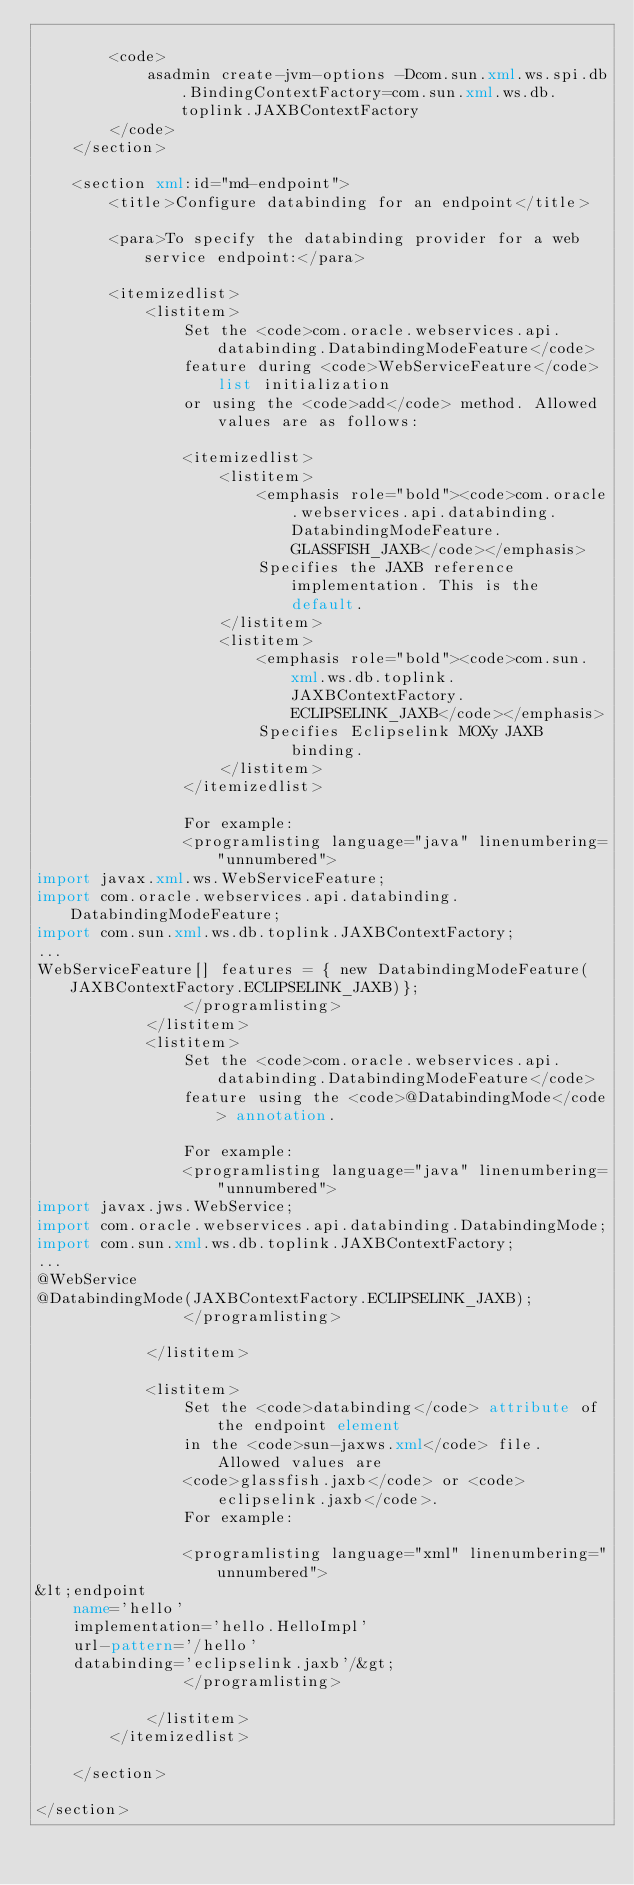<code> <loc_0><loc_0><loc_500><loc_500><_XML_>
        <code>
            asadmin create-jvm-options -Dcom.sun.xml.ws.spi.db.BindingContextFactory=com.sun.xml.ws.db.toplink.JAXBContextFactory
        </code>
    </section>

    <section xml:id="md-endpoint">
        <title>Configure databinding for an endpoint</title>

        <para>To specify the databinding provider for a web service endpoint:</para>

        <itemizedlist>
            <listitem>
                Set the <code>com.oracle.webservices.api.databinding.DatabindingModeFeature</code> 
                feature during <code>WebServiceFeature</code> list initialization
                or using the <code>add</code> method. Allowed values are as follows:

                <itemizedlist>
                    <listitem>
                        <emphasis role="bold"><code>com.oracle.webservices.api.databinding.DatabindingModeFeature.GLASSFISH_JAXB</code></emphasis>
                        Specifies the JAXB reference implementation. This is the default.
                    </listitem>
                    <listitem>
                        <emphasis role="bold"><code>com.sun.xml.ws.db.toplink.JAXBContextFactory.ECLIPSELINK_JAXB</code></emphasis>
                        Specifies Eclipselink MOXy JAXB binding.
                    </listitem>
                </itemizedlist>

                For example:
                <programlisting language="java" linenumbering="unnumbered">
import javax.xml.ws.WebServiceFeature;
import com.oracle.webservices.api.databinding.DatabindingModeFeature;
import com.sun.xml.ws.db.toplink.JAXBContextFactory;
...
WebServiceFeature[] features = { new DatabindingModeFeature(JAXBContextFactory.ECLIPSELINK_JAXB)};
                </programlisting>                    
            </listitem>
            <listitem>
                Set the <code>com.oracle.webservices.api.databinding.DatabindingModeFeature</code> 
                feature using the <code>@DatabindingMode</code> annotation.

                For example:
                <programlisting language="java" linenumbering="unnumbered">
import javax.jws.WebService;
import com.oracle.webservices.api.databinding.DatabindingMode;
import com.sun.xml.ws.db.toplink.JAXBContextFactory;
...
@WebService
@DatabindingMode(JAXBContextFactory.ECLIPSELINK_JAXB);
                </programlisting>

            </listitem>

            <listitem>
                Set the <code>databinding</code> attribute of the endpoint element 
                in the <code>sun-jaxws.xml</code> file. Allowed values are 
                <code>glassfish.jaxb</code> or <code>eclipselink.jaxb</code>.
                For example:

                <programlisting language="xml" linenumbering="unnumbered">
&lt;endpoint
    name='hello'
    implementation='hello.HelloImpl'
    url-pattern='/hello'
    databinding='eclipselink.jaxb'/&gt;
                </programlisting>

            </listitem>
        </itemizedlist>

    </section>

</section>
</code> 